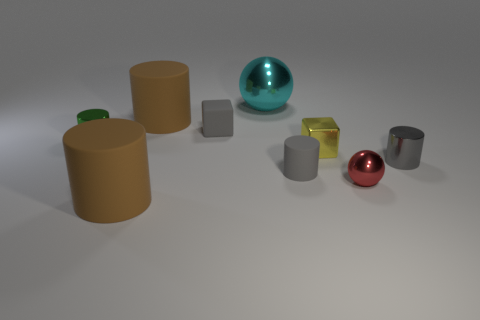Subtract all cyan cylinders. Subtract all yellow blocks. How many cylinders are left? 5 Add 1 yellow matte cubes. How many objects exist? 10 Subtract all cylinders. How many objects are left? 4 Subtract 1 gray cylinders. How many objects are left? 8 Subtract all green shiny spheres. Subtract all tiny metal things. How many objects are left? 5 Add 2 small gray shiny cylinders. How many small gray shiny cylinders are left? 3 Add 8 blue rubber spheres. How many blue rubber spheres exist? 8 